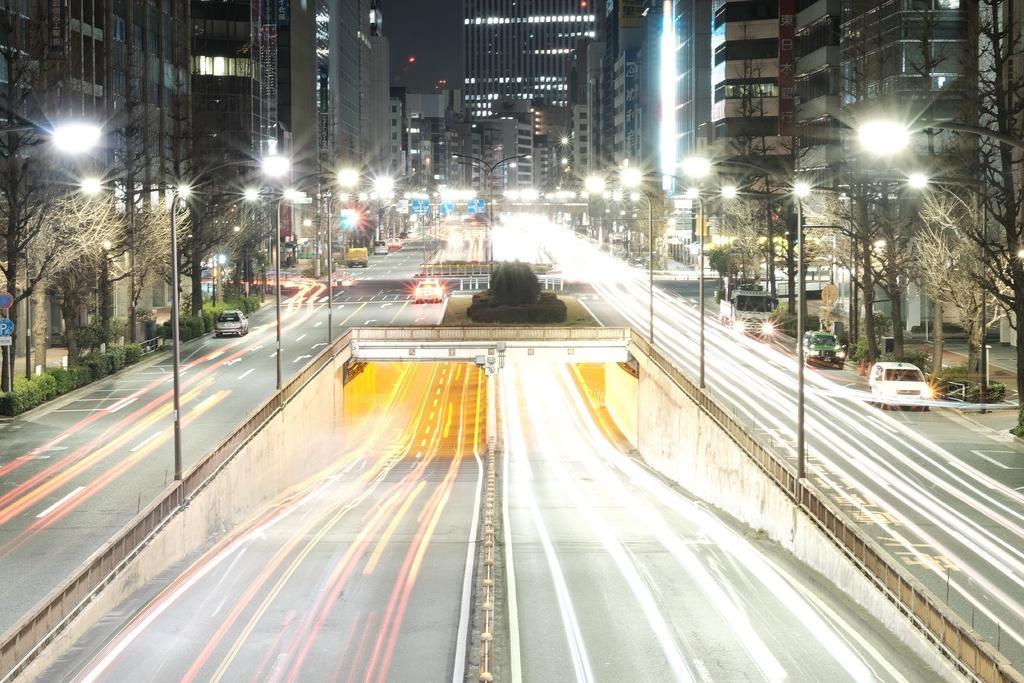Could you give a brief overview of what you see in this image? In this image we can see buildings with windows, light poles, trees and we can also see some vehicles on the road. 